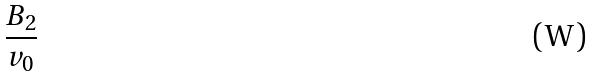<formula> <loc_0><loc_0><loc_500><loc_500>\frac { B _ { 2 } } { v _ { 0 } }</formula> 